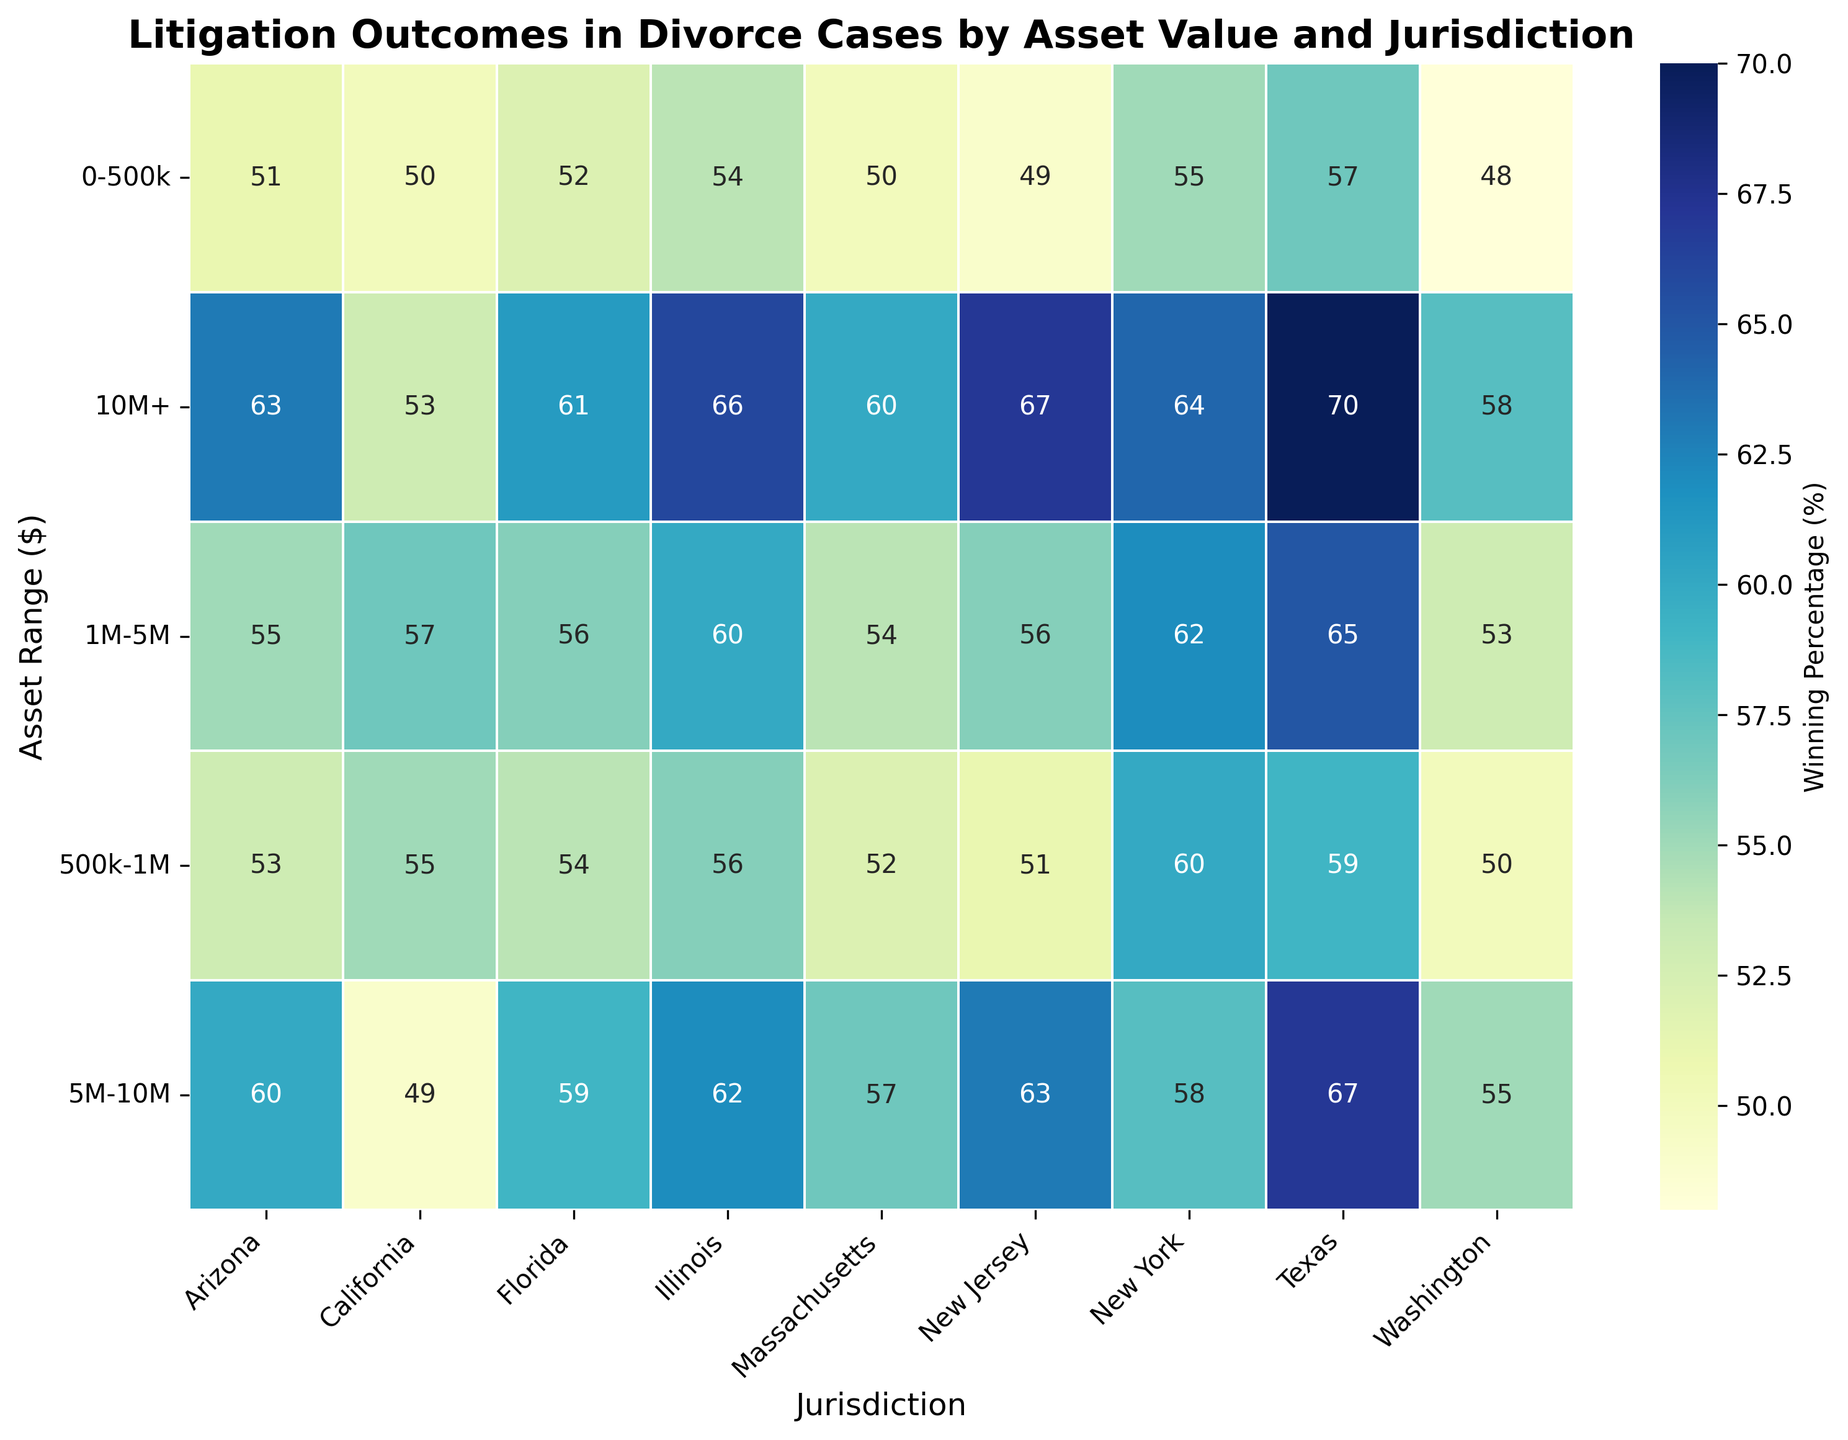Which jurisdiction has the highest winning percentage for the original holder in cases with assets above $10M? Look at the values corresponding to the highest asset range ($10M+) across all jurisdictions. Identify the highest value.
Answer: Texas What is the difference in winning percentage between New York and California for cases with assets between $1M and $5M? Locate the winning percentages for both jurisdictions in the $1M-$5M asset range row and calculate their difference: 62% (New York) - 57% (California).
Answer: 5% Which asset range in Arizona shows the highest winning percentage for the original holder? Examine the percentages for all asset ranges under Arizona and identify the highest value. Compare visually across all ranges.
Answer: $10M+ What is the average winning percentage for the original holder in Illinois for all asset values? Add up the winning percentages for all asset ranges in Illinois and divide by the number of ranges: (54 + 56 + 60 + 62 + 66)/5.
Answer: 59.6% Between which asset ranges does Texas show a consistent increase in winning percentage? Look at the winning percentages for Texas across all asset ranges. Identify where the percentages steadily increase: 57% (0-500k), 59% (500k-1M), 65% (1M-5M), 67% (5M-10M), 70% (10M+).
Answer: All ranges For the jurisdiction with the lowest winning percentage in the 0-500k asset range, what is the winning percentage? Identify the lowest value in the 0-500k asset range across all jurisdictions.
Answer: Washington (48%) What is the overall trend in winning percentages as asset values increase in Florida? Examine the trend of winning percentages across increasing asset ranges in Florida. Identify if they increase, decrease, or fluctuate: 52% -> 54% -> 56% -> 59% -> 61%.
Answer: Increase Compare the winning percentages for the original holder in the $1M-$5M asset range between Massachusetts and New Jersey. Which shows greater winning odds? Look at the $1M-$5M row for both jurisdictions and compare the values: 54% (Massachusetts), 56% (New Jersey).
Answer: New Jersey How does the winning percentage for the original holder in Washington for assets between $5M and $10M compare to that in Arizona for the same range? Identify and compare the values in the $5M-$10M row for both jurisdictions: Washington (55%), Arizona (60%).
Answer: Arizona What is the trend in winning percentages for the original holder across asset ranges in New Jersey? Analyze the values across all asset ranges in New Jersey to identify if they increase, decrease, or fluctuate: 49% -> 51% -> 56% -> 63% -> 67%.
Answer: Increase 